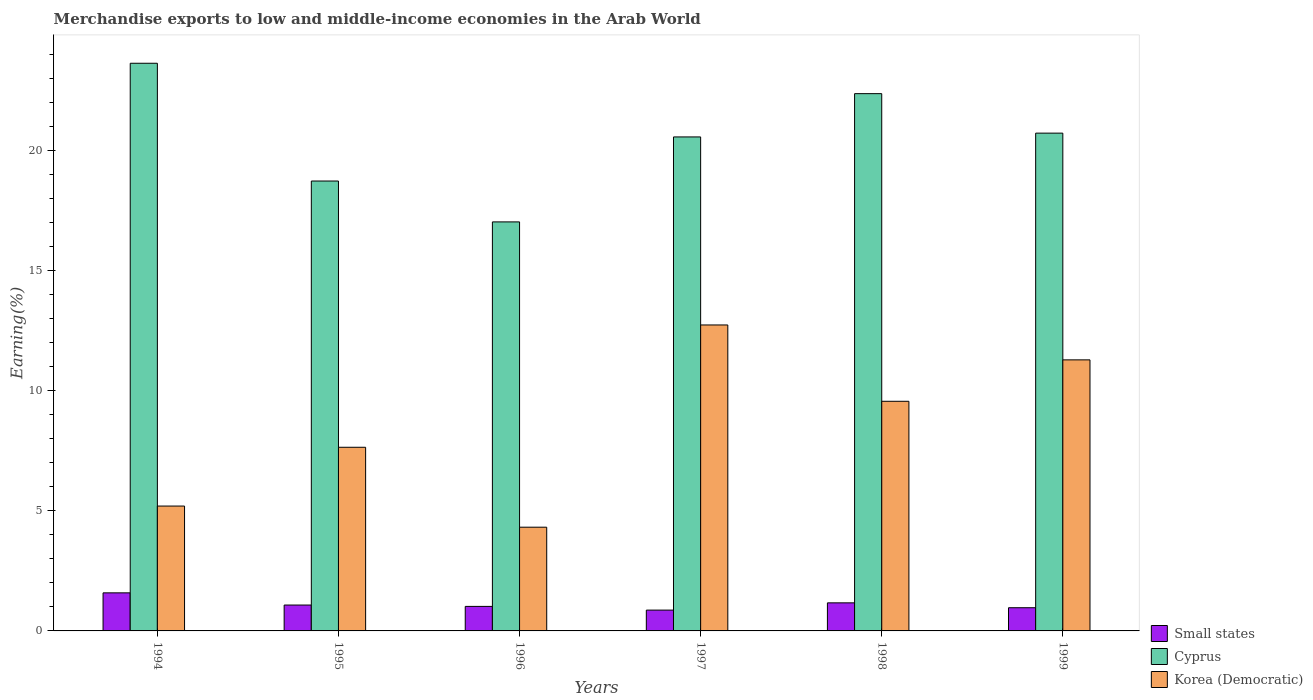How many different coloured bars are there?
Your response must be concise. 3. Are the number of bars per tick equal to the number of legend labels?
Offer a very short reply. Yes. How many bars are there on the 2nd tick from the right?
Offer a very short reply. 3. What is the percentage of amount earned from merchandise exports in Korea (Democratic) in 1995?
Keep it short and to the point. 7.65. Across all years, what is the maximum percentage of amount earned from merchandise exports in Small states?
Your answer should be very brief. 1.59. Across all years, what is the minimum percentage of amount earned from merchandise exports in Small states?
Provide a short and direct response. 0.87. In which year was the percentage of amount earned from merchandise exports in Korea (Democratic) minimum?
Provide a short and direct response. 1996. What is the total percentage of amount earned from merchandise exports in Small states in the graph?
Your response must be concise. 6.69. What is the difference between the percentage of amount earned from merchandise exports in Small states in 1994 and that in 1999?
Offer a very short reply. 0.62. What is the difference between the percentage of amount earned from merchandise exports in Small states in 1994 and the percentage of amount earned from merchandise exports in Korea (Democratic) in 1995?
Provide a short and direct response. -6.06. What is the average percentage of amount earned from merchandise exports in Small states per year?
Provide a succinct answer. 1.11. In the year 1994, what is the difference between the percentage of amount earned from merchandise exports in Korea (Democratic) and percentage of amount earned from merchandise exports in Small states?
Your response must be concise. 3.62. In how many years, is the percentage of amount earned from merchandise exports in Small states greater than 20 %?
Provide a succinct answer. 0. What is the ratio of the percentage of amount earned from merchandise exports in Small states in 1998 to that in 1999?
Your answer should be compact. 1.21. What is the difference between the highest and the second highest percentage of amount earned from merchandise exports in Korea (Democratic)?
Ensure brevity in your answer.  1.45. What is the difference between the highest and the lowest percentage of amount earned from merchandise exports in Cyprus?
Ensure brevity in your answer.  6.61. Is the sum of the percentage of amount earned from merchandise exports in Korea (Democratic) in 1997 and 1999 greater than the maximum percentage of amount earned from merchandise exports in Small states across all years?
Ensure brevity in your answer.  Yes. What does the 1st bar from the left in 1996 represents?
Provide a succinct answer. Small states. What does the 2nd bar from the right in 1994 represents?
Your answer should be very brief. Cyprus. Is it the case that in every year, the sum of the percentage of amount earned from merchandise exports in Small states and percentage of amount earned from merchandise exports in Korea (Democratic) is greater than the percentage of amount earned from merchandise exports in Cyprus?
Your answer should be very brief. No. How many bars are there?
Give a very brief answer. 18. Are all the bars in the graph horizontal?
Your answer should be compact. No. Where does the legend appear in the graph?
Keep it short and to the point. Bottom right. How are the legend labels stacked?
Ensure brevity in your answer.  Vertical. What is the title of the graph?
Your answer should be compact. Merchandise exports to low and middle-income economies in the Arab World. Does "Angola" appear as one of the legend labels in the graph?
Offer a very short reply. No. What is the label or title of the Y-axis?
Make the answer very short. Earning(%). What is the Earning(%) in Small states in 1994?
Ensure brevity in your answer.  1.59. What is the Earning(%) in Cyprus in 1994?
Provide a succinct answer. 23.65. What is the Earning(%) of Korea (Democratic) in 1994?
Provide a succinct answer. 5.2. What is the Earning(%) in Small states in 1995?
Offer a terse response. 1.08. What is the Earning(%) in Cyprus in 1995?
Your response must be concise. 18.74. What is the Earning(%) in Korea (Democratic) in 1995?
Provide a succinct answer. 7.65. What is the Earning(%) in Small states in 1996?
Keep it short and to the point. 1.02. What is the Earning(%) in Cyprus in 1996?
Your answer should be compact. 17.04. What is the Earning(%) in Korea (Democratic) in 1996?
Ensure brevity in your answer.  4.32. What is the Earning(%) in Small states in 1997?
Your answer should be compact. 0.87. What is the Earning(%) of Cyprus in 1997?
Ensure brevity in your answer.  20.58. What is the Earning(%) in Korea (Democratic) in 1997?
Offer a terse response. 12.74. What is the Earning(%) of Small states in 1998?
Make the answer very short. 1.17. What is the Earning(%) in Cyprus in 1998?
Make the answer very short. 22.38. What is the Earning(%) in Korea (Democratic) in 1998?
Provide a succinct answer. 9.57. What is the Earning(%) of Small states in 1999?
Offer a terse response. 0.97. What is the Earning(%) of Cyprus in 1999?
Provide a succinct answer. 20.74. What is the Earning(%) of Korea (Democratic) in 1999?
Your response must be concise. 11.29. Across all years, what is the maximum Earning(%) in Small states?
Provide a succinct answer. 1.59. Across all years, what is the maximum Earning(%) of Cyprus?
Provide a short and direct response. 23.65. Across all years, what is the maximum Earning(%) in Korea (Democratic)?
Make the answer very short. 12.74. Across all years, what is the minimum Earning(%) of Small states?
Ensure brevity in your answer.  0.87. Across all years, what is the minimum Earning(%) of Cyprus?
Provide a succinct answer. 17.04. Across all years, what is the minimum Earning(%) in Korea (Democratic)?
Give a very brief answer. 4.32. What is the total Earning(%) in Small states in the graph?
Provide a short and direct response. 6.69. What is the total Earning(%) in Cyprus in the graph?
Make the answer very short. 123.12. What is the total Earning(%) in Korea (Democratic) in the graph?
Your answer should be very brief. 50.77. What is the difference between the Earning(%) in Small states in 1994 and that in 1995?
Offer a very short reply. 0.51. What is the difference between the Earning(%) of Cyprus in 1994 and that in 1995?
Provide a short and direct response. 4.91. What is the difference between the Earning(%) in Korea (Democratic) in 1994 and that in 1995?
Ensure brevity in your answer.  -2.45. What is the difference between the Earning(%) in Small states in 1994 and that in 1996?
Keep it short and to the point. 0.56. What is the difference between the Earning(%) of Cyprus in 1994 and that in 1996?
Give a very brief answer. 6.61. What is the difference between the Earning(%) of Korea (Democratic) in 1994 and that in 1996?
Provide a succinct answer. 0.88. What is the difference between the Earning(%) in Small states in 1994 and that in 1997?
Your answer should be compact. 0.72. What is the difference between the Earning(%) of Cyprus in 1994 and that in 1997?
Provide a succinct answer. 3.07. What is the difference between the Earning(%) in Korea (Democratic) in 1994 and that in 1997?
Provide a succinct answer. -7.54. What is the difference between the Earning(%) in Small states in 1994 and that in 1998?
Keep it short and to the point. 0.42. What is the difference between the Earning(%) of Cyprus in 1994 and that in 1998?
Provide a succinct answer. 1.27. What is the difference between the Earning(%) in Korea (Democratic) in 1994 and that in 1998?
Your answer should be very brief. -4.36. What is the difference between the Earning(%) of Small states in 1994 and that in 1999?
Give a very brief answer. 0.62. What is the difference between the Earning(%) of Cyprus in 1994 and that in 1999?
Provide a succinct answer. 2.91. What is the difference between the Earning(%) of Korea (Democratic) in 1994 and that in 1999?
Provide a short and direct response. -6.09. What is the difference between the Earning(%) in Small states in 1995 and that in 1996?
Give a very brief answer. 0.06. What is the difference between the Earning(%) of Cyprus in 1995 and that in 1996?
Offer a terse response. 1.7. What is the difference between the Earning(%) in Korea (Democratic) in 1995 and that in 1996?
Your answer should be compact. 3.33. What is the difference between the Earning(%) in Small states in 1995 and that in 1997?
Keep it short and to the point. 0.21. What is the difference between the Earning(%) of Cyprus in 1995 and that in 1997?
Give a very brief answer. -1.84. What is the difference between the Earning(%) of Korea (Democratic) in 1995 and that in 1997?
Provide a short and direct response. -5.1. What is the difference between the Earning(%) of Small states in 1995 and that in 1998?
Give a very brief answer. -0.09. What is the difference between the Earning(%) of Cyprus in 1995 and that in 1998?
Your response must be concise. -3.64. What is the difference between the Earning(%) in Korea (Democratic) in 1995 and that in 1998?
Your answer should be very brief. -1.92. What is the difference between the Earning(%) of Small states in 1995 and that in 1999?
Your response must be concise. 0.11. What is the difference between the Earning(%) of Cyprus in 1995 and that in 1999?
Offer a very short reply. -1.99. What is the difference between the Earning(%) in Korea (Democratic) in 1995 and that in 1999?
Provide a short and direct response. -3.64. What is the difference between the Earning(%) in Small states in 1996 and that in 1997?
Offer a very short reply. 0.15. What is the difference between the Earning(%) in Cyprus in 1996 and that in 1997?
Make the answer very short. -3.54. What is the difference between the Earning(%) of Korea (Democratic) in 1996 and that in 1997?
Your answer should be very brief. -8.42. What is the difference between the Earning(%) of Small states in 1996 and that in 1998?
Provide a short and direct response. -0.15. What is the difference between the Earning(%) in Cyprus in 1996 and that in 1998?
Give a very brief answer. -5.34. What is the difference between the Earning(%) of Korea (Democratic) in 1996 and that in 1998?
Your response must be concise. -5.24. What is the difference between the Earning(%) in Small states in 1996 and that in 1999?
Provide a short and direct response. 0.05. What is the difference between the Earning(%) of Cyprus in 1996 and that in 1999?
Ensure brevity in your answer.  -3.7. What is the difference between the Earning(%) of Korea (Democratic) in 1996 and that in 1999?
Your answer should be compact. -6.97. What is the difference between the Earning(%) in Small states in 1997 and that in 1998?
Give a very brief answer. -0.3. What is the difference between the Earning(%) in Cyprus in 1997 and that in 1998?
Ensure brevity in your answer.  -1.8. What is the difference between the Earning(%) in Korea (Democratic) in 1997 and that in 1998?
Offer a terse response. 3.18. What is the difference between the Earning(%) of Small states in 1997 and that in 1999?
Give a very brief answer. -0.1. What is the difference between the Earning(%) of Cyprus in 1997 and that in 1999?
Your answer should be very brief. -0.16. What is the difference between the Earning(%) of Korea (Democratic) in 1997 and that in 1999?
Your answer should be very brief. 1.45. What is the difference between the Earning(%) of Small states in 1998 and that in 1999?
Give a very brief answer. 0.2. What is the difference between the Earning(%) of Cyprus in 1998 and that in 1999?
Ensure brevity in your answer.  1.64. What is the difference between the Earning(%) in Korea (Democratic) in 1998 and that in 1999?
Your answer should be very brief. -1.73. What is the difference between the Earning(%) of Small states in 1994 and the Earning(%) of Cyprus in 1995?
Ensure brevity in your answer.  -17.15. What is the difference between the Earning(%) in Small states in 1994 and the Earning(%) in Korea (Democratic) in 1995?
Provide a short and direct response. -6.06. What is the difference between the Earning(%) in Cyprus in 1994 and the Earning(%) in Korea (Democratic) in 1995?
Offer a very short reply. 16. What is the difference between the Earning(%) of Small states in 1994 and the Earning(%) of Cyprus in 1996?
Offer a terse response. -15.45. What is the difference between the Earning(%) of Small states in 1994 and the Earning(%) of Korea (Democratic) in 1996?
Offer a terse response. -2.74. What is the difference between the Earning(%) of Cyprus in 1994 and the Earning(%) of Korea (Democratic) in 1996?
Give a very brief answer. 19.33. What is the difference between the Earning(%) of Small states in 1994 and the Earning(%) of Cyprus in 1997?
Offer a terse response. -18.99. What is the difference between the Earning(%) in Small states in 1994 and the Earning(%) in Korea (Democratic) in 1997?
Offer a very short reply. -11.16. What is the difference between the Earning(%) of Cyprus in 1994 and the Earning(%) of Korea (Democratic) in 1997?
Ensure brevity in your answer.  10.9. What is the difference between the Earning(%) in Small states in 1994 and the Earning(%) in Cyprus in 1998?
Your answer should be very brief. -20.79. What is the difference between the Earning(%) in Small states in 1994 and the Earning(%) in Korea (Democratic) in 1998?
Give a very brief answer. -7.98. What is the difference between the Earning(%) in Cyprus in 1994 and the Earning(%) in Korea (Democratic) in 1998?
Your response must be concise. 14.08. What is the difference between the Earning(%) of Small states in 1994 and the Earning(%) of Cyprus in 1999?
Your response must be concise. -19.15. What is the difference between the Earning(%) in Small states in 1994 and the Earning(%) in Korea (Democratic) in 1999?
Offer a very short reply. -9.71. What is the difference between the Earning(%) of Cyprus in 1994 and the Earning(%) of Korea (Democratic) in 1999?
Keep it short and to the point. 12.36. What is the difference between the Earning(%) of Small states in 1995 and the Earning(%) of Cyprus in 1996?
Provide a succinct answer. -15.96. What is the difference between the Earning(%) in Small states in 1995 and the Earning(%) in Korea (Democratic) in 1996?
Ensure brevity in your answer.  -3.24. What is the difference between the Earning(%) of Cyprus in 1995 and the Earning(%) of Korea (Democratic) in 1996?
Keep it short and to the point. 14.42. What is the difference between the Earning(%) of Small states in 1995 and the Earning(%) of Cyprus in 1997?
Provide a short and direct response. -19.5. What is the difference between the Earning(%) in Small states in 1995 and the Earning(%) in Korea (Democratic) in 1997?
Your answer should be very brief. -11.67. What is the difference between the Earning(%) in Cyprus in 1995 and the Earning(%) in Korea (Democratic) in 1997?
Provide a succinct answer. 6. What is the difference between the Earning(%) in Small states in 1995 and the Earning(%) in Cyprus in 1998?
Provide a succinct answer. -21.3. What is the difference between the Earning(%) of Small states in 1995 and the Earning(%) of Korea (Democratic) in 1998?
Give a very brief answer. -8.49. What is the difference between the Earning(%) of Cyprus in 1995 and the Earning(%) of Korea (Democratic) in 1998?
Offer a terse response. 9.18. What is the difference between the Earning(%) in Small states in 1995 and the Earning(%) in Cyprus in 1999?
Offer a terse response. -19.66. What is the difference between the Earning(%) of Small states in 1995 and the Earning(%) of Korea (Democratic) in 1999?
Your response must be concise. -10.21. What is the difference between the Earning(%) of Cyprus in 1995 and the Earning(%) of Korea (Democratic) in 1999?
Offer a terse response. 7.45. What is the difference between the Earning(%) in Small states in 1996 and the Earning(%) in Cyprus in 1997?
Give a very brief answer. -19.56. What is the difference between the Earning(%) of Small states in 1996 and the Earning(%) of Korea (Democratic) in 1997?
Your response must be concise. -11.72. What is the difference between the Earning(%) of Cyprus in 1996 and the Earning(%) of Korea (Democratic) in 1997?
Offer a very short reply. 4.29. What is the difference between the Earning(%) in Small states in 1996 and the Earning(%) in Cyprus in 1998?
Offer a very short reply. -21.36. What is the difference between the Earning(%) in Small states in 1996 and the Earning(%) in Korea (Democratic) in 1998?
Your answer should be very brief. -8.54. What is the difference between the Earning(%) of Cyprus in 1996 and the Earning(%) of Korea (Democratic) in 1998?
Make the answer very short. 7.47. What is the difference between the Earning(%) of Small states in 1996 and the Earning(%) of Cyprus in 1999?
Your answer should be very brief. -19.71. What is the difference between the Earning(%) in Small states in 1996 and the Earning(%) in Korea (Democratic) in 1999?
Your answer should be very brief. -10.27. What is the difference between the Earning(%) in Cyprus in 1996 and the Earning(%) in Korea (Democratic) in 1999?
Provide a short and direct response. 5.75. What is the difference between the Earning(%) of Small states in 1997 and the Earning(%) of Cyprus in 1998?
Keep it short and to the point. -21.51. What is the difference between the Earning(%) of Small states in 1997 and the Earning(%) of Korea (Democratic) in 1998?
Your response must be concise. -8.7. What is the difference between the Earning(%) in Cyprus in 1997 and the Earning(%) in Korea (Democratic) in 1998?
Your answer should be very brief. 11.01. What is the difference between the Earning(%) in Small states in 1997 and the Earning(%) in Cyprus in 1999?
Provide a short and direct response. -19.87. What is the difference between the Earning(%) of Small states in 1997 and the Earning(%) of Korea (Democratic) in 1999?
Provide a succinct answer. -10.42. What is the difference between the Earning(%) in Cyprus in 1997 and the Earning(%) in Korea (Democratic) in 1999?
Offer a terse response. 9.29. What is the difference between the Earning(%) of Small states in 1998 and the Earning(%) of Cyprus in 1999?
Provide a short and direct response. -19.57. What is the difference between the Earning(%) of Small states in 1998 and the Earning(%) of Korea (Democratic) in 1999?
Ensure brevity in your answer.  -10.12. What is the difference between the Earning(%) of Cyprus in 1998 and the Earning(%) of Korea (Democratic) in 1999?
Keep it short and to the point. 11.09. What is the average Earning(%) of Small states per year?
Give a very brief answer. 1.11. What is the average Earning(%) of Cyprus per year?
Your answer should be very brief. 20.52. What is the average Earning(%) in Korea (Democratic) per year?
Give a very brief answer. 8.46. In the year 1994, what is the difference between the Earning(%) of Small states and Earning(%) of Cyprus?
Provide a short and direct response. -22.06. In the year 1994, what is the difference between the Earning(%) in Small states and Earning(%) in Korea (Democratic)?
Your response must be concise. -3.62. In the year 1994, what is the difference between the Earning(%) of Cyprus and Earning(%) of Korea (Democratic)?
Your answer should be compact. 18.45. In the year 1995, what is the difference between the Earning(%) in Small states and Earning(%) in Cyprus?
Give a very brief answer. -17.66. In the year 1995, what is the difference between the Earning(%) of Small states and Earning(%) of Korea (Democratic)?
Provide a succinct answer. -6.57. In the year 1995, what is the difference between the Earning(%) of Cyprus and Earning(%) of Korea (Democratic)?
Your answer should be very brief. 11.09. In the year 1996, what is the difference between the Earning(%) in Small states and Earning(%) in Cyprus?
Offer a very short reply. -16.02. In the year 1996, what is the difference between the Earning(%) in Small states and Earning(%) in Korea (Democratic)?
Ensure brevity in your answer.  -3.3. In the year 1996, what is the difference between the Earning(%) of Cyprus and Earning(%) of Korea (Democratic)?
Ensure brevity in your answer.  12.72. In the year 1997, what is the difference between the Earning(%) in Small states and Earning(%) in Cyprus?
Your response must be concise. -19.71. In the year 1997, what is the difference between the Earning(%) of Small states and Earning(%) of Korea (Democratic)?
Provide a succinct answer. -11.88. In the year 1997, what is the difference between the Earning(%) of Cyprus and Earning(%) of Korea (Democratic)?
Offer a terse response. 7.83. In the year 1998, what is the difference between the Earning(%) in Small states and Earning(%) in Cyprus?
Give a very brief answer. -21.21. In the year 1998, what is the difference between the Earning(%) in Small states and Earning(%) in Korea (Democratic)?
Offer a terse response. -8.4. In the year 1998, what is the difference between the Earning(%) in Cyprus and Earning(%) in Korea (Democratic)?
Offer a very short reply. 12.82. In the year 1999, what is the difference between the Earning(%) of Small states and Earning(%) of Cyprus?
Provide a short and direct response. -19.77. In the year 1999, what is the difference between the Earning(%) of Small states and Earning(%) of Korea (Democratic)?
Ensure brevity in your answer.  -10.32. In the year 1999, what is the difference between the Earning(%) of Cyprus and Earning(%) of Korea (Democratic)?
Your response must be concise. 9.44. What is the ratio of the Earning(%) of Small states in 1994 to that in 1995?
Offer a terse response. 1.47. What is the ratio of the Earning(%) in Cyprus in 1994 to that in 1995?
Your answer should be very brief. 1.26. What is the ratio of the Earning(%) in Korea (Democratic) in 1994 to that in 1995?
Your answer should be very brief. 0.68. What is the ratio of the Earning(%) in Small states in 1994 to that in 1996?
Offer a terse response. 1.55. What is the ratio of the Earning(%) in Cyprus in 1994 to that in 1996?
Keep it short and to the point. 1.39. What is the ratio of the Earning(%) in Korea (Democratic) in 1994 to that in 1996?
Your answer should be very brief. 1.2. What is the ratio of the Earning(%) of Small states in 1994 to that in 1997?
Provide a short and direct response. 1.83. What is the ratio of the Earning(%) of Cyprus in 1994 to that in 1997?
Offer a terse response. 1.15. What is the ratio of the Earning(%) of Korea (Democratic) in 1994 to that in 1997?
Offer a terse response. 0.41. What is the ratio of the Earning(%) of Small states in 1994 to that in 1998?
Keep it short and to the point. 1.36. What is the ratio of the Earning(%) in Cyprus in 1994 to that in 1998?
Your answer should be compact. 1.06. What is the ratio of the Earning(%) in Korea (Democratic) in 1994 to that in 1998?
Provide a short and direct response. 0.54. What is the ratio of the Earning(%) of Small states in 1994 to that in 1999?
Offer a terse response. 1.64. What is the ratio of the Earning(%) of Cyprus in 1994 to that in 1999?
Make the answer very short. 1.14. What is the ratio of the Earning(%) of Korea (Democratic) in 1994 to that in 1999?
Your answer should be compact. 0.46. What is the ratio of the Earning(%) in Small states in 1995 to that in 1996?
Offer a very short reply. 1.06. What is the ratio of the Earning(%) in Cyprus in 1995 to that in 1996?
Ensure brevity in your answer.  1.1. What is the ratio of the Earning(%) in Korea (Democratic) in 1995 to that in 1996?
Make the answer very short. 1.77. What is the ratio of the Earning(%) of Small states in 1995 to that in 1997?
Your answer should be compact. 1.24. What is the ratio of the Earning(%) of Cyprus in 1995 to that in 1997?
Your answer should be very brief. 0.91. What is the ratio of the Earning(%) in Korea (Democratic) in 1995 to that in 1997?
Provide a short and direct response. 0.6. What is the ratio of the Earning(%) of Small states in 1995 to that in 1998?
Your answer should be compact. 0.92. What is the ratio of the Earning(%) of Cyprus in 1995 to that in 1998?
Your answer should be very brief. 0.84. What is the ratio of the Earning(%) in Korea (Democratic) in 1995 to that in 1998?
Make the answer very short. 0.8. What is the ratio of the Earning(%) in Small states in 1995 to that in 1999?
Offer a very short reply. 1.12. What is the ratio of the Earning(%) in Cyprus in 1995 to that in 1999?
Your answer should be compact. 0.9. What is the ratio of the Earning(%) of Korea (Democratic) in 1995 to that in 1999?
Give a very brief answer. 0.68. What is the ratio of the Earning(%) of Small states in 1996 to that in 1997?
Provide a succinct answer. 1.18. What is the ratio of the Earning(%) in Cyprus in 1996 to that in 1997?
Offer a very short reply. 0.83. What is the ratio of the Earning(%) in Korea (Democratic) in 1996 to that in 1997?
Offer a very short reply. 0.34. What is the ratio of the Earning(%) in Small states in 1996 to that in 1998?
Your answer should be very brief. 0.87. What is the ratio of the Earning(%) of Cyprus in 1996 to that in 1998?
Offer a very short reply. 0.76. What is the ratio of the Earning(%) of Korea (Democratic) in 1996 to that in 1998?
Offer a terse response. 0.45. What is the ratio of the Earning(%) in Small states in 1996 to that in 1999?
Your answer should be compact. 1.06. What is the ratio of the Earning(%) of Cyprus in 1996 to that in 1999?
Offer a terse response. 0.82. What is the ratio of the Earning(%) of Korea (Democratic) in 1996 to that in 1999?
Ensure brevity in your answer.  0.38. What is the ratio of the Earning(%) in Small states in 1997 to that in 1998?
Make the answer very short. 0.74. What is the ratio of the Earning(%) in Cyprus in 1997 to that in 1998?
Ensure brevity in your answer.  0.92. What is the ratio of the Earning(%) of Korea (Democratic) in 1997 to that in 1998?
Make the answer very short. 1.33. What is the ratio of the Earning(%) in Small states in 1997 to that in 1999?
Offer a very short reply. 0.9. What is the ratio of the Earning(%) in Korea (Democratic) in 1997 to that in 1999?
Your answer should be very brief. 1.13. What is the ratio of the Earning(%) of Small states in 1998 to that in 1999?
Make the answer very short. 1.21. What is the ratio of the Earning(%) in Cyprus in 1998 to that in 1999?
Make the answer very short. 1.08. What is the ratio of the Earning(%) in Korea (Democratic) in 1998 to that in 1999?
Provide a succinct answer. 0.85. What is the difference between the highest and the second highest Earning(%) of Small states?
Keep it short and to the point. 0.42. What is the difference between the highest and the second highest Earning(%) in Cyprus?
Your answer should be compact. 1.27. What is the difference between the highest and the second highest Earning(%) of Korea (Democratic)?
Make the answer very short. 1.45. What is the difference between the highest and the lowest Earning(%) in Small states?
Give a very brief answer. 0.72. What is the difference between the highest and the lowest Earning(%) in Cyprus?
Your response must be concise. 6.61. What is the difference between the highest and the lowest Earning(%) in Korea (Democratic)?
Keep it short and to the point. 8.42. 